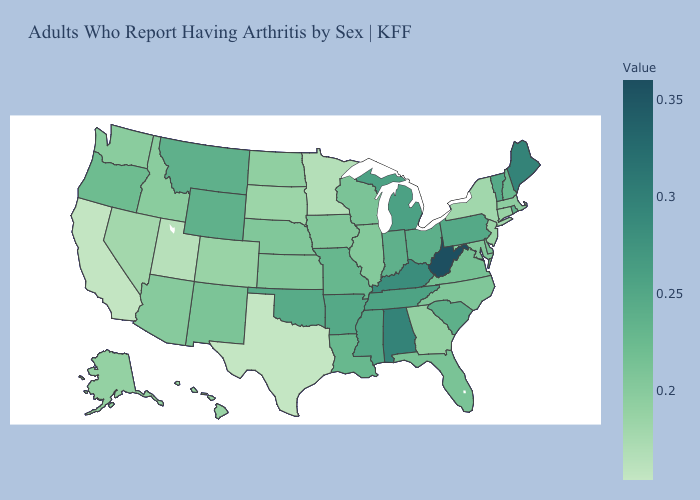Does California have a higher value than West Virginia?
Give a very brief answer. No. Among the states that border Mississippi , does Alabama have the highest value?
Be succinct. Yes. Which states hav the highest value in the MidWest?
Quick response, please. Michigan. Does Utah have the lowest value in the West?
Answer briefly. No. Is the legend a continuous bar?
Concise answer only. Yes. Which states have the lowest value in the USA?
Quick response, please. Texas. Does Nebraska have a higher value than Oklahoma?
Be succinct. No. Among the states that border North Dakota , does Minnesota have the lowest value?
Write a very short answer. Yes. 